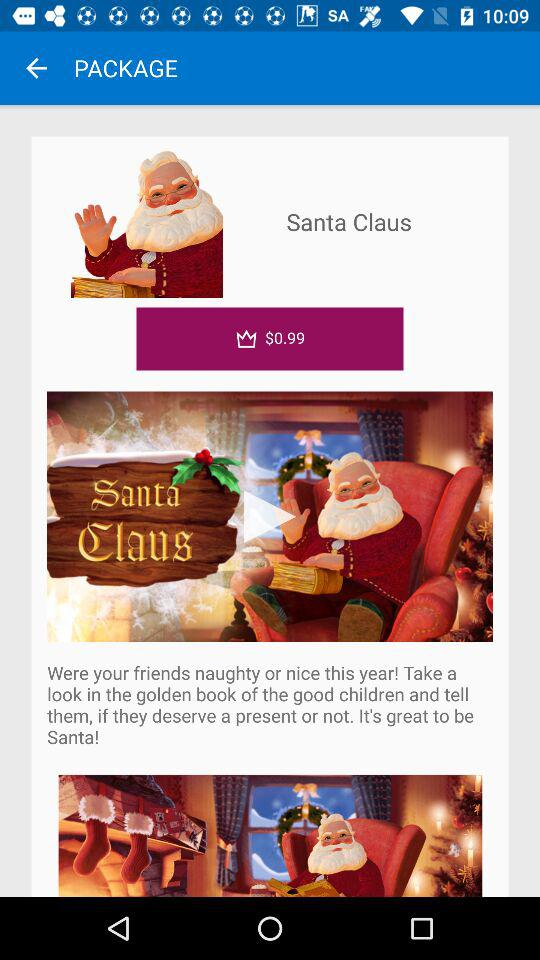How much does the book cost in dollars? The book costs $0.99. 